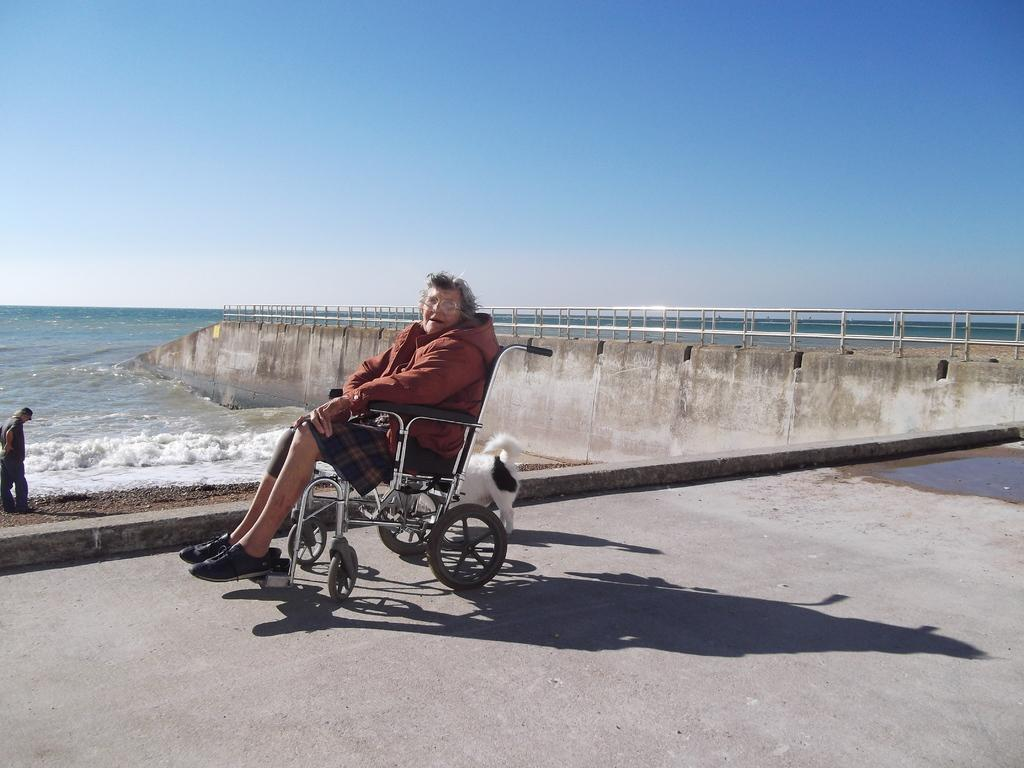What is the main subject of the image? There is a woman in a wheelchair in the image. Can you describe the person standing behind the woman? There is a person standing behind the woman in the image. What can be seen in the background of the image? Water and a metal fence are visible in the background of the image. What type of juice is being served in the image? There is no juice present in the image. Can you see any steam coming from the metal fence in the background? There is no steam visible in the image. 